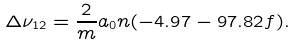Convert formula to latex. <formula><loc_0><loc_0><loc_500><loc_500>\Delta \nu _ { 1 2 } = \frac { 2 } { m } a _ { 0 } n ( - 4 . 9 7 - 9 7 . 8 2 f ) .</formula> 